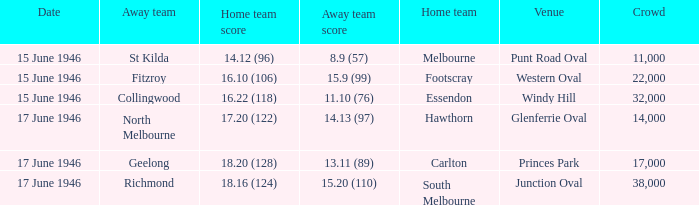On which date did a home team achieve a score of 1 15 June 1946. 